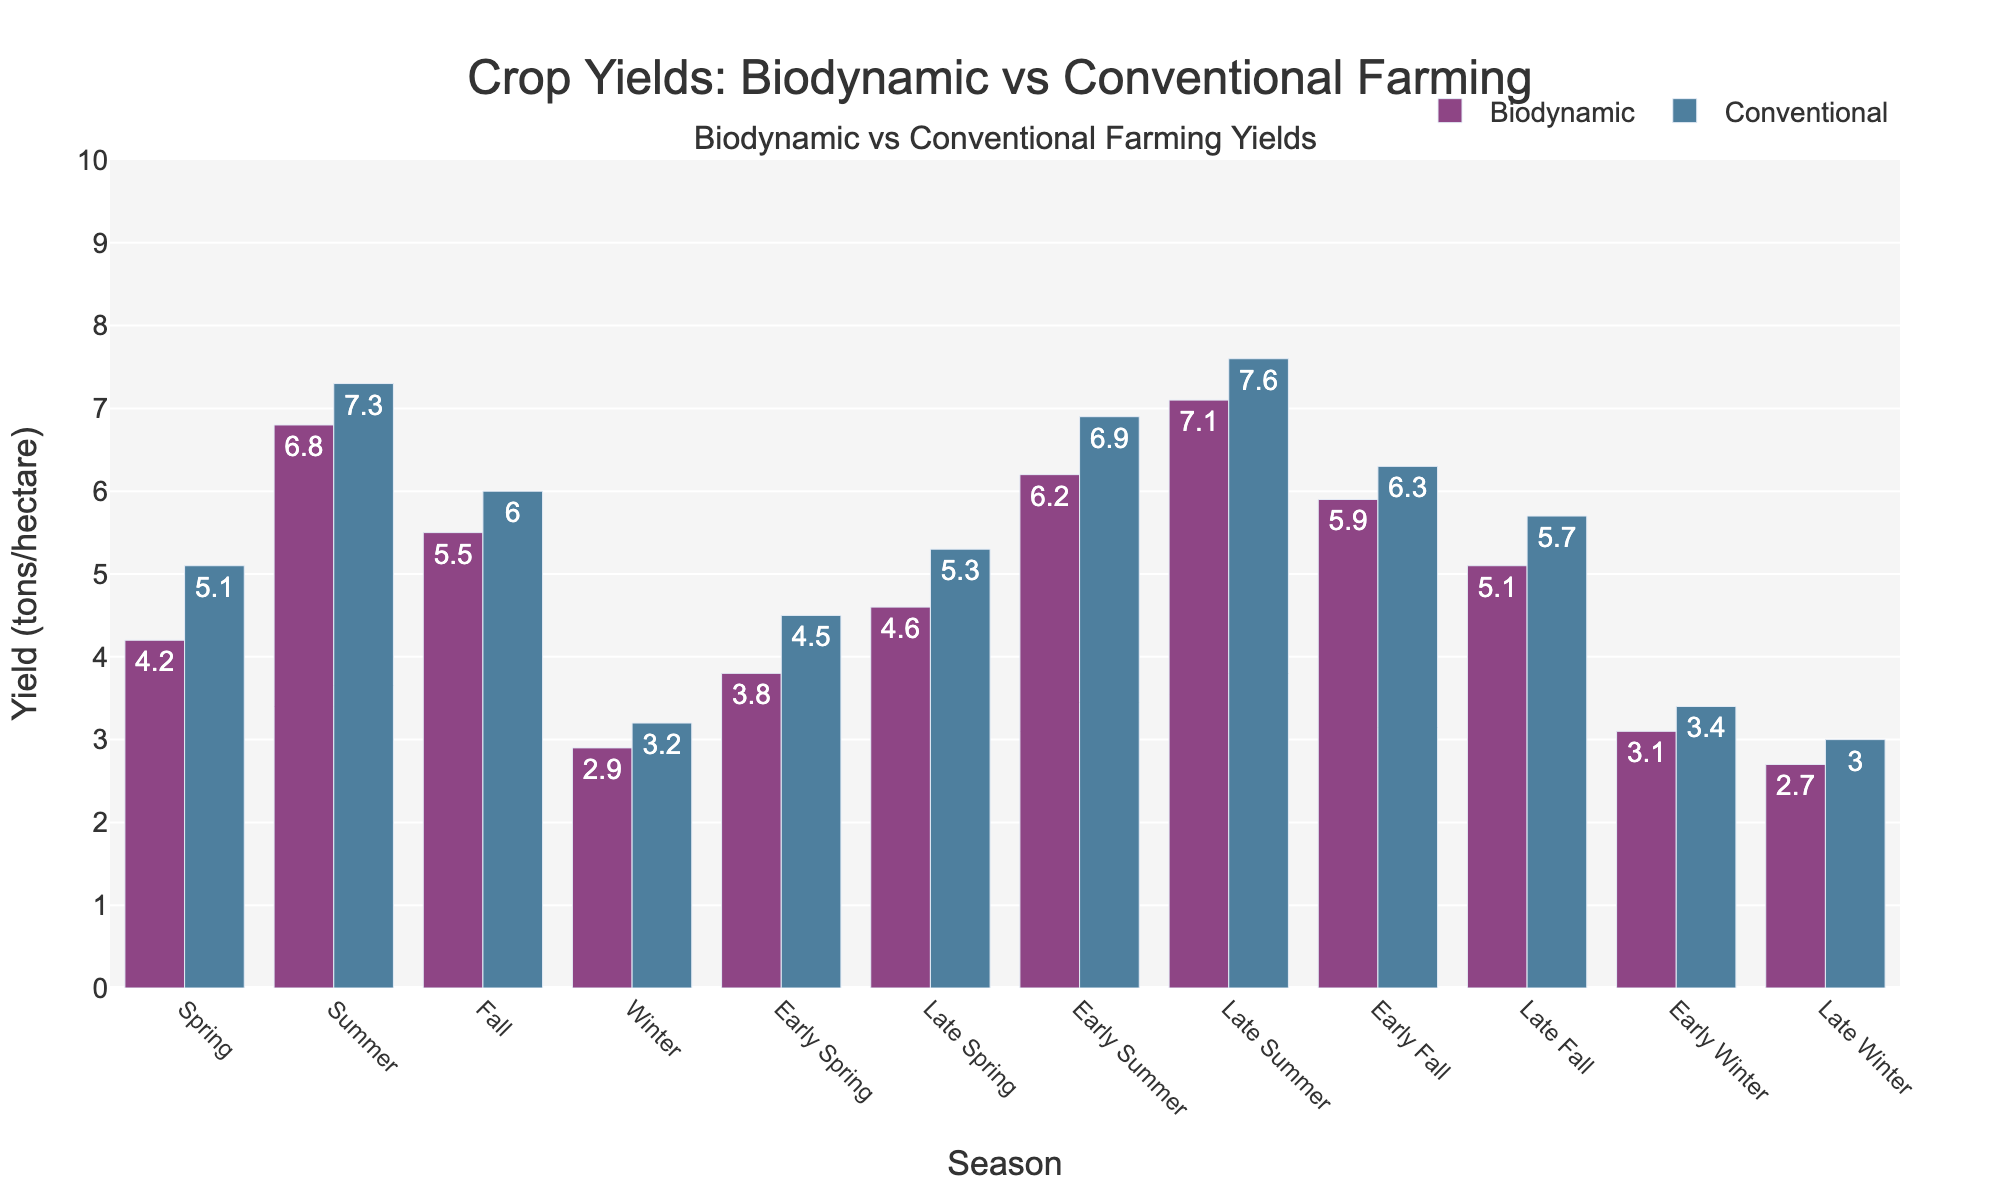Which farming method had the highest yield in summer? By visually comparing the heights of the bars representing summer in the bar chart, we can see that the bar for Conventional farming is slightly higher than the bar for Biodynamic farming for the summer season.
Answer: Conventional What is the yield difference between Biodynamic and Conventional farming in fall? To find the difference, look at the bars for the fall season in the chart and subtract the Biodynamic yield (5.5) from the Conventional yield (6.0).
Answer: 0.5 tons/hectare Which season shows the smallest difference in yield between Biodynamic and Conventional farming methods? By comparing the yield differences across all seasons visually, it appears that Early Winter has the smallest difference between the Biodynamic yield (3.1) and the Conventional yield (3.4).
Answer: Early Winter What is the combined yield for both farming methods in late summer? Combine the yields from both farming methods in late summer by adding Biodynamic yield (7.1) and Conventional yield (7.6) together.
Answer: 14.7 tons/hectare Did any of the seasons have equal yields in both farming methods? Compare the heights of bars for both methods across all seasons. There is no season where the Biodynamic and Conventional yields are equal.
Answer: No Which season has the highest Biodynamic yield? By visually comparing the heights of the bars representing Biodynamic yield across all seasons, we can see that Late Summer has the highest Biodynamic yield (7.1).
Answer: Late Summer Which yields more in Early Spring: Biodynamic farming or Biodynamic farming in Early Winter? Compare the heights of the bars for Early Spring and Early Winter under Biodynamic farming, where Early Spring (3.8) is greater than Early Winter (3.1).
Answer: Early Spring How much lower is the Biodynamic yield in late winter compared to early winter? Subtract the Biodynamic yield in late winter (2.7) from that in early winter (3.1).
Answer: 0.4 tons/hectare What is the median yield of Biodynamic farming across the listed seasons? Arrange the Biodynamic yields in order (2.7, 2.9, 3.1, 3.8, 4.2, 4.6, 5.1, 5.5, 5.9, 6.2, 6.8, 7.1) and find the middle value. For twelve numbers, the median is the average of the 6th and 7th values, (4.6 + 5.1) / 2.
Answer: 4.85 tons/hectare In which season are yields closer between the two farming methods: Early Fall or Late Fall? Compare the differences in yields for Early Fall (0.4) and Late Fall (0.6) visually. Early Fall has a smaller difference.
Answer: Early Fall 